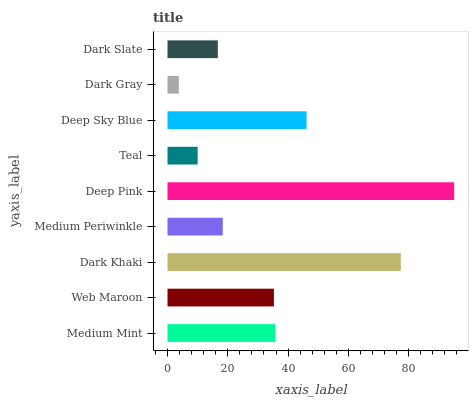Is Dark Gray the minimum?
Answer yes or no. Yes. Is Deep Pink the maximum?
Answer yes or no. Yes. Is Web Maroon the minimum?
Answer yes or no. No. Is Web Maroon the maximum?
Answer yes or no. No. Is Medium Mint greater than Web Maroon?
Answer yes or no. Yes. Is Web Maroon less than Medium Mint?
Answer yes or no. Yes. Is Web Maroon greater than Medium Mint?
Answer yes or no. No. Is Medium Mint less than Web Maroon?
Answer yes or no. No. Is Web Maroon the high median?
Answer yes or no. Yes. Is Web Maroon the low median?
Answer yes or no. Yes. Is Deep Sky Blue the high median?
Answer yes or no. No. Is Medium Mint the low median?
Answer yes or no. No. 